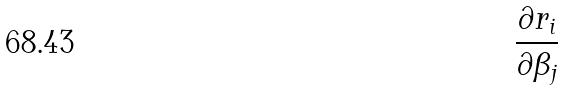Convert formula to latex. <formula><loc_0><loc_0><loc_500><loc_500>\frac { \partial r _ { i } } { \partial \beta _ { j } }</formula> 